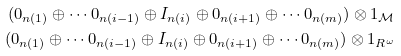Convert formula to latex. <formula><loc_0><loc_0><loc_500><loc_500>( 0 _ { n ( 1 ) } \oplus \cdots 0 _ { n ( i - 1 ) } \oplus I _ { n ( i ) } \oplus 0 _ { n ( i + 1 ) } \oplus \cdots 0 _ { n ( m ) } ) \otimes 1 _ { \mathcal { M } } \\ ( 0 _ { n ( 1 ) } \oplus \cdots 0 _ { n ( i - 1 ) } \oplus I _ { n ( i ) } \oplus 0 _ { n ( i + 1 ) } \oplus \cdots 0 _ { n ( m ) } ) \otimes 1 _ { R ^ { \omega } }</formula> 